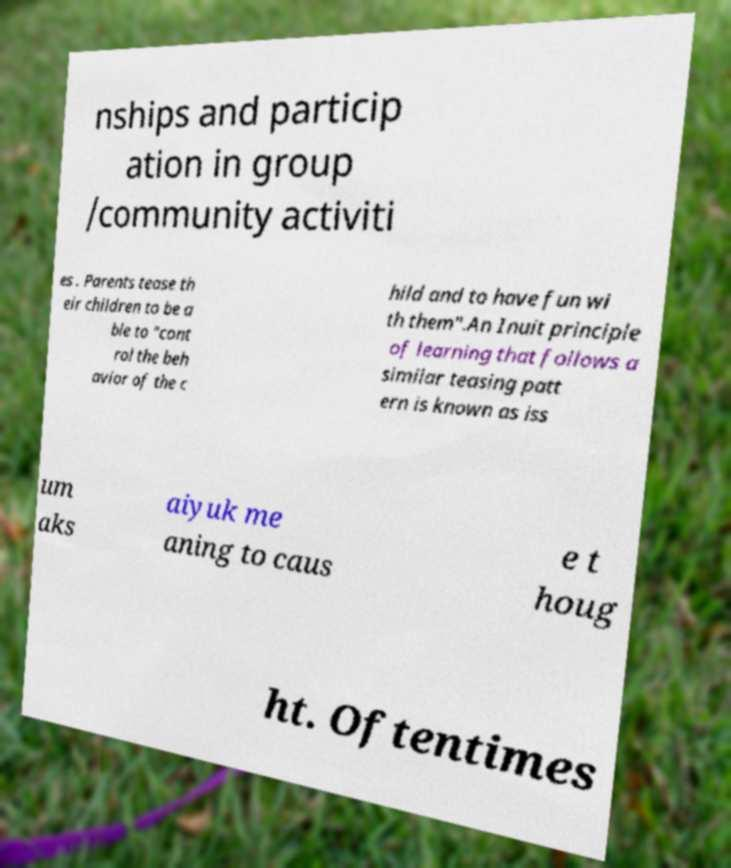Please identify and transcribe the text found in this image. nships and particip ation in group /community activiti es . Parents tease th eir children to be a ble to "cont rol the beh avior of the c hild and to have fun wi th them".An Inuit principle of learning that follows a similar teasing patt ern is known as iss um aks aiyuk me aning to caus e t houg ht. Oftentimes 